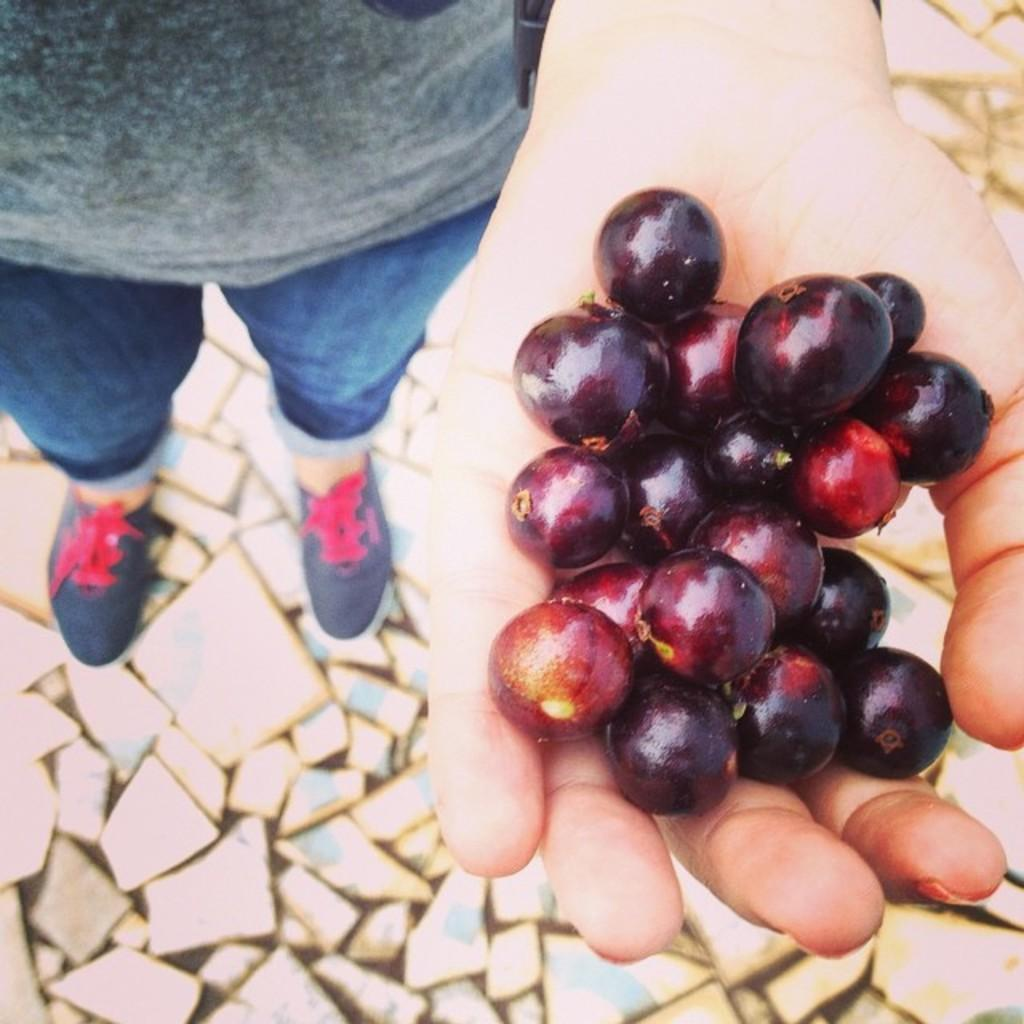What type of fruit is visible in the image? There are grapes in the image. How are the grapes being held in the image? The grapes are held by a human hand. What can be seen on the ground in the image? There are stones on the ground in the image. What type of fuel is being used by the person holding the grapes in the image? There is no mention of fuel or any fuel-related activity in the image. 